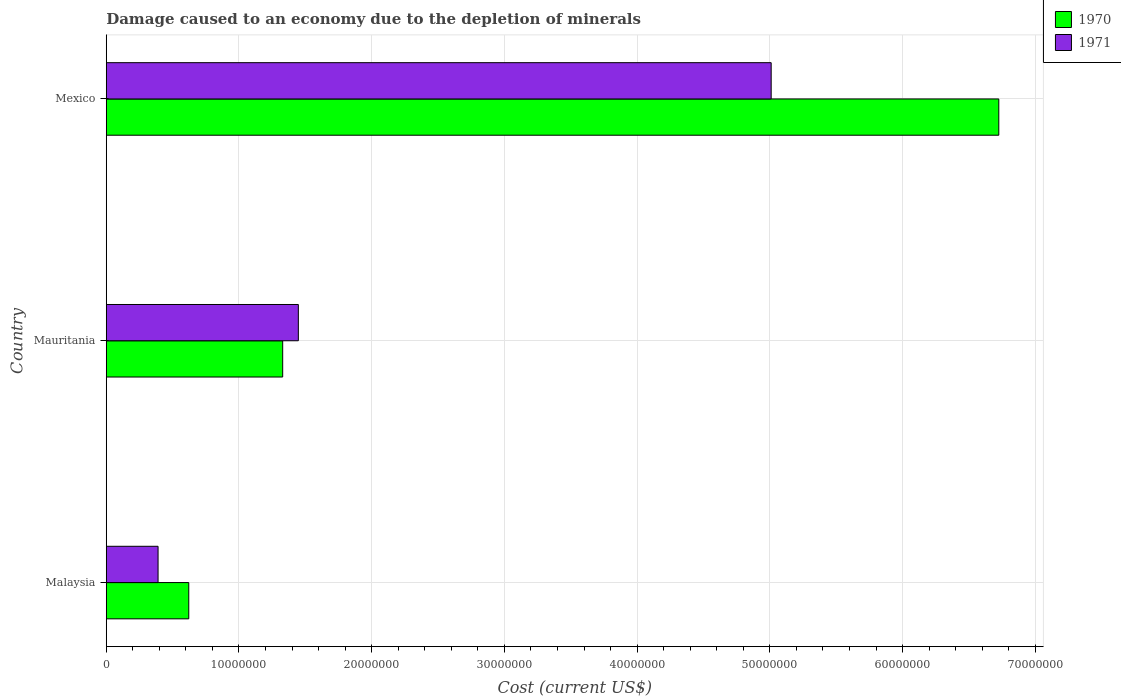How many different coloured bars are there?
Provide a short and direct response. 2. How many groups of bars are there?
Provide a succinct answer. 3. Are the number of bars on each tick of the Y-axis equal?
Your response must be concise. Yes. How many bars are there on the 1st tick from the top?
Offer a very short reply. 2. How many bars are there on the 2nd tick from the bottom?
Provide a short and direct response. 2. What is the label of the 2nd group of bars from the top?
Provide a succinct answer. Mauritania. What is the cost of damage caused due to the depletion of minerals in 1971 in Malaysia?
Offer a very short reply. 3.90e+06. Across all countries, what is the maximum cost of damage caused due to the depletion of minerals in 1970?
Give a very brief answer. 6.73e+07. Across all countries, what is the minimum cost of damage caused due to the depletion of minerals in 1970?
Your response must be concise. 6.22e+06. In which country was the cost of damage caused due to the depletion of minerals in 1970 maximum?
Give a very brief answer. Mexico. In which country was the cost of damage caused due to the depletion of minerals in 1971 minimum?
Keep it short and to the point. Malaysia. What is the total cost of damage caused due to the depletion of minerals in 1970 in the graph?
Offer a very short reply. 8.68e+07. What is the difference between the cost of damage caused due to the depletion of minerals in 1971 in Mauritania and that in Mexico?
Keep it short and to the point. -3.56e+07. What is the difference between the cost of damage caused due to the depletion of minerals in 1970 in Mauritania and the cost of damage caused due to the depletion of minerals in 1971 in Malaysia?
Provide a succinct answer. 9.39e+06. What is the average cost of damage caused due to the depletion of minerals in 1970 per country?
Make the answer very short. 2.89e+07. What is the difference between the cost of damage caused due to the depletion of minerals in 1971 and cost of damage caused due to the depletion of minerals in 1970 in Mauritania?
Give a very brief answer. 1.18e+06. What is the ratio of the cost of damage caused due to the depletion of minerals in 1971 in Mauritania to that in Mexico?
Offer a terse response. 0.29. Is the difference between the cost of damage caused due to the depletion of minerals in 1971 in Mauritania and Mexico greater than the difference between the cost of damage caused due to the depletion of minerals in 1970 in Mauritania and Mexico?
Keep it short and to the point. Yes. What is the difference between the highest and the second highest cost of damage caused due to the depletion of minerals in 1971?
Provide a succinct answer. 3.56e+07. What is the difference between the highest and the lowest cost of damage caused due to the depletion of minerals in 1970?
Keep it short and to the point. 6.10e+07. In how many countries, is the cost of damage caused due to the depletion of minerals in 1970 greater than the average cost of damage caused due to the depletion of minerals in 1970 taken over all countries?
Provide a succinct answer. 1. Is the sum of the cost of damage caused due to the depletion of minerals in 1970 in Mauritania and Mexico greater than the maximum cost of damage caused due to the depletion of minerals in 1971 across all countries?
Give a very brief answer. Yes. What does the 2nd bar from the top in Mauritania represents?
Give a very brief answer. 1970. What does the 2nd bar from the bottom in Malaysia represents?
Keep it short and to the point. 1971. What is the difference between two consecutive major ticks on the X-axis?
Your answer should be compact. 1.00e+07. Are the values on the major ticks of X-axis written in scientific E-notation?
Provide a succinct answer. No. Does the graph contain grids?
Give a very brief answer. Yes. Where does the legend appear in the graph?
Provide a succinct answer. Top right. How are the legend labels stacked?
Your answer should be compact. Vertical. What is the title of the graph?
Your answer should be very brief. Damage caused to an economy due to the depletion of minerals. What is the label or title of the X-axis?
Provide a short and direct response. Cost (current US$). What is the label or title of the Y-axis?
Make the answer very short. Country. What is the Cost (current US$) of 1970 in Malaysia?
Your answer should be very brief. 6.22e+06. What is the Cost (current US$) in 1971 in Malaysia?
Offer a terse response. 3.90e+06. What is the Cost (current US$) in 1970 in Mauritania?
Ensure brevity in your answer.  1.33e+07. What is the Cost (current US$) in 1971 in Mauritania?
Your response must be concise. 1.45e+07. What is the Cost (current US$) of 1970 in Mexico?
Keep it short and to the point. 6.73e+07. What is the Cost (current US$) in 1971 in Mexico?
Your answer should be very brief. 5.01e+07. Across all countries, what is the maximum Cost (current US$) in 1970?
Your answer should be very brief. 6.73e+07. Across all countries, what is the maximum Cost (current US$) of 1971?
Your response must be concise. 5.01e+07. Across all countries, what is the minimum Cost (current US$) of 1970?
Your answer should be very brief. 6.22e+06. Across all countries, what is the minimum Cost (current US$) in 1971?
Provide a succinct answer. 3.90e+06. What is the total Cost (current US$) in 1970 in the graph?
Give a very brief answer. 8.68e+07. What is the total Cost (current US$) of 1971 in the graph?
Your response must be concise. 6.85e+07. What is the difference between the Cost (current US$) of 1970 in Malaysia and that in Mauritania?
Your answer should be compact. -7.08e+06. What is the difference between the Cost (current US$) in 1971 in Malaysia and that in Mauritania?
Ensure brevity in your answer.  -1.06e+07. What is the difference between the Cost (current US$) in 1970 in Malaysia and that in Mexico?
Keep it short and to the point. -6.10e+07. What is the difference between the Cost (current US$) of 1971 in Malaysia and that in Mexico?
Make the answer very short. -4.62e+07. What is the difference between the Cost (current US$) of 1970 in Mauritania and that in Mexico?
Give a very brief answer. -5.40e+07. What is the difference between the Cost (current US$) in 1971 in Mauritania and that in Mexico?
Give a very brief answer. -3.56e+07. What is the difference between the Cost (current US$) in 1970 in Malaysia and the Cost (current US$) in 1971 in Mauritania?
Ensure brevity in your answer.  -8.26e+06. What is the difference between the Cost (current US$) of 1970 in Malaysia and the Cost (current US$) of 1971 in Mexico?
Keep it short and to the point. -4.39e+07. What is the difference between the Cost (current US$) of 1970 in Mauritania and the Cost (current US$) of 1971 in Mexico?
Offer a very short reply. -3.68e+07. What is the average Cost (current US$) in 1970 per country?
Provide a short and direct response. 2.89e+07. What is the average Cost (current US$) of 1971 per country?
Provide a succinct answer. 2.28e+07. What is the difference between the Cost (current US$) in 1970 and Cost (current US$) in 1971 in Malaysia?
Make the answer very short. 2.31e+06. What is the difference between the Cost (current US$) of 1970 and Cost (current US$) of 1971 in Mauritania?
Offer a terse response. -1.18e+06. What is the difference between the Cost (current US$) of 1970 and Cost (current US$) of 1971 in Mexico?
Offer a terse response. 1.72e+07. What is the ratio of the Cost (current US$) of 1970 in Malaysia to that in Mauritania?
Provide a short and direct response. 0.47. What is the ratio of the Cost (current US$) in 1971 in Malaysia to that in Mauritania?
Offer a terse response. 0.27. What is the ratio of the Cost (current US$) in 1970 in Malaysia to that in Mexico?
Your answer should be very brief. 0.09. What is the ratio of the Cost (current US$) in 1971 in Malaysia to that in Mexico?
Offer a very short reply. 0.08. What is the ratio of the Cost (current US$) in 1970 in Mauritania to that in Mexico?
Offer a terse response. 0.2. What is the ratio of the Cost (current US$) of 1971 in Mauritania to that in Mexico?
Offer a very short reply. 0.29. What is the difference between the highest and the second highest Cost (current US$) of 1970?
Give a very brief answer. 5.40e+07. What is the difference between the highest and the second highest Cost (current US$) in 1971?
Provide a short and direct response. 3.56e+07. What is the difference between the highest and the lowest Cost (current US$) of 1970?
Offer a terse response. 6.10e+07. What is the difference between the highest and the lowest Cost (current US$) in 1971?
Your answer should be very brief. 4.62e+07. 